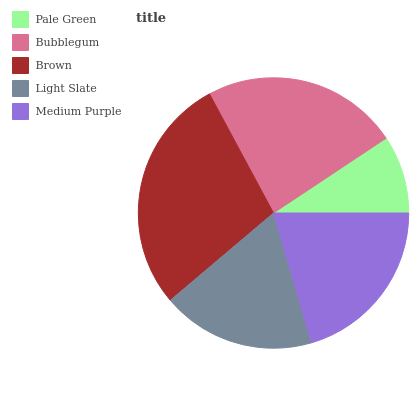Is Pale Green the minimum?
Answer yes or no. Yes. Is Brown the maximum?
Answer yes or no. Yes. Is Bubblegum the minimum?
Answer yes or no. No. Is Bubblegum the maximum?
Answer yes or no. No. Is Bubblegum greater than Pale Green?
Answer yes or no. Yes. Is Pale Green less than Bubblegum?
Answer yes or no. Yes. Is Pale Green greater than Bubblegum?
Answer yes or no. No. Is Bubblegum less than Pale Green?
Answer yes or no. No. Is Medium Purple the high median?
Answer yes or no. Yes. Is Medium Purple the low median?
Answer yes or no. Yes. Is Light Slate the high median?
Answer yes or no. No. Is Pale Green the low median?
Answer yes or no. No. 